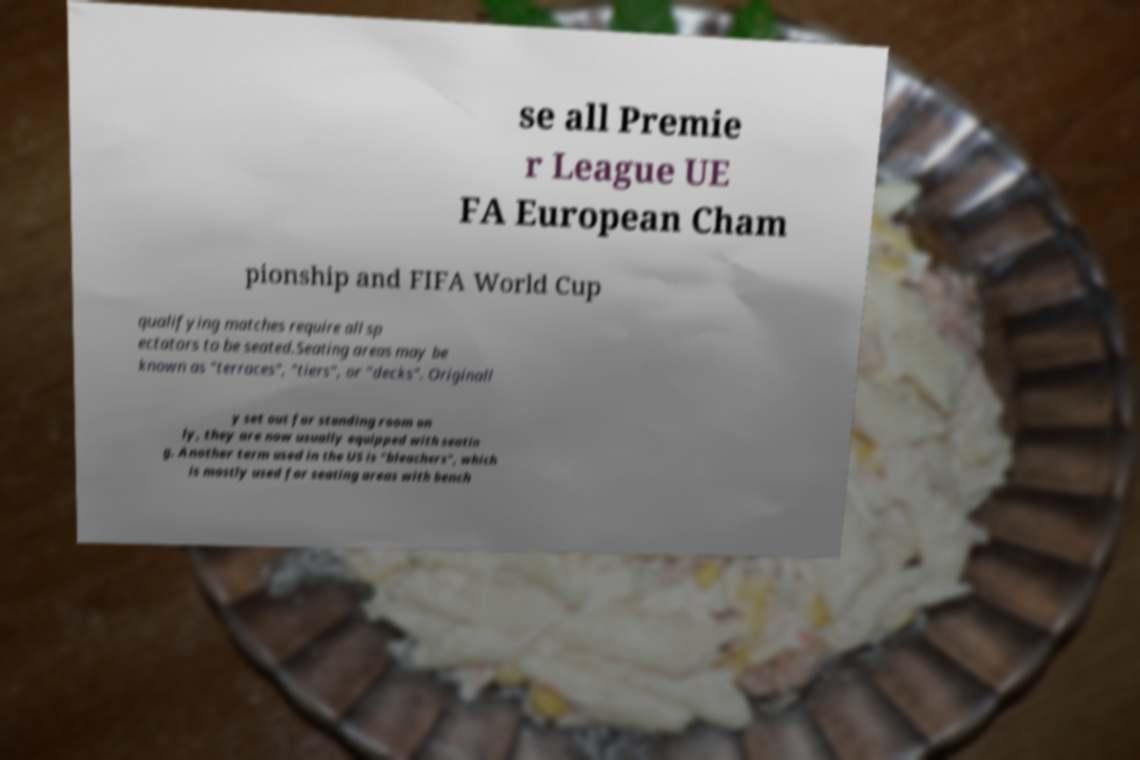There's text embedded in this image that I need extracted. Can you transcribe it verbatim? se all Premie r League UE FA European Cham pionship and FIFA World Cup qualifying matches require all sp ectators to be seated.Seating areas may be known as "terraces", "tiers", or "decks". Originall y set out for standing room on ly, they are now usually equipped with seatin g. Another term used in the US is "bleachers", which is mostly used for seating areas with bench 